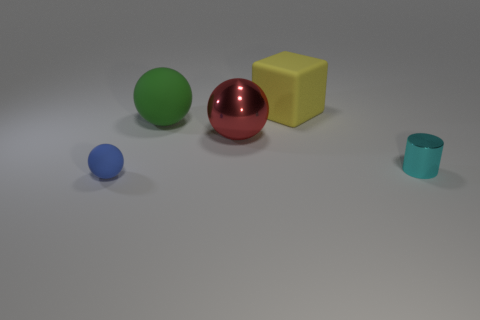How many red objects have the same shape as the blue matte thing?
Offer a very short reply. 1. Are there any metal things of the same color as the small rubber ball?
Provide a succinct answer. No. What number of things are spheres that are behind the tiny rubber thing or small things left of the big block?
Ensure brevity in your answer.  3. There is a tiny thing on the right side of the large yellow object; is there a rubber sphere that is in front of it?
Give a very brief answer. Yes. There is a blue matte object that is the same size as the cyan metallic thing; what shape is it?
Your answer should be compact. Sphere. How many things are metal objects on the left side of the rubber cube or green spheres?
Keep it short and to the point. 2. How many other things are made of the same material as the red sphere?
Keep it short and to the point. 1. What size is the thing to the left of the green thing?
Keep it short and to the point. Small. What shape is the large yellow object that is the same material as the blue sphere?
Give a very brief answer. Cube. Are the block and the big ball in front of the big matte sphere made of the same material?
Ensure brevity in your answer.  No. 